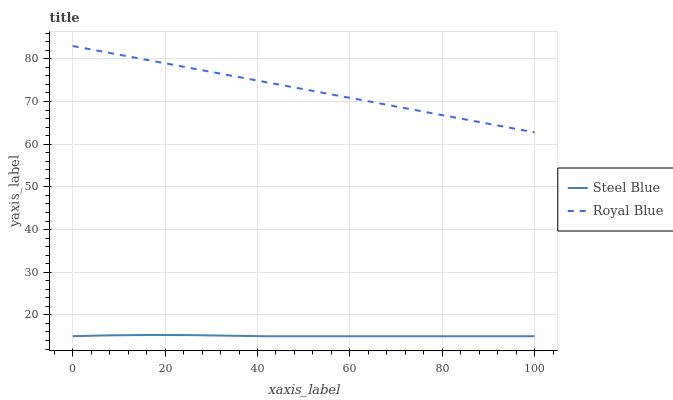Does Steel Blue have the minimum area under the curve?
Answer yes or no. Yes. Does Royal Blue have the maximum area under the curve?
Answer yes or no. Yes. Does Steel Blue have the maximum area under the curve?
Answer yes or no. No. Is Royal Blue the smoothest?
Answer yes or no. Yes. Is Steel Blue the roughest?
Answer yes or no. Yes. Is Steel Blue the smoothest?
Answer yes or no. No. Does Steel Blue have the lowest value?
Answer yes or no. Yes. Does Royal Blue have the highest value?
Answer yes or no. Yes. Does Steel Blue have the highest value?
Answer yes or no. No. Is Steel Blue less than Royal Blue?
Answer yes or no. Yes. Is Royal Blue greater than Steel Blue?
Answer yes or no. Yes. Does Steel Blue intersect Royal Blue?
Answer yes or no. No. 